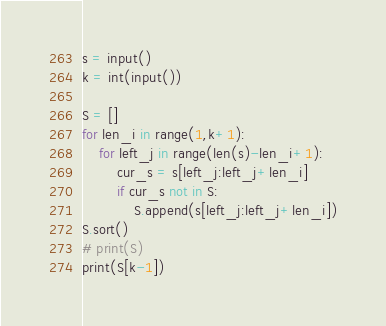<code> <loc_0><loc_0><loc_500><loc_500><_Python_>s = input()
k = int(input())

S = []
for len_i in range(1,k+1):
	for left_j in range(len(s)-len_i+1):
		cur_s = s[left_j:left_j+len_i]
		if cur_s not in S:
			S.append(s[left_j:left_j+len_i])
S.sort()
# print(S)
print(S[k-1])</code> 